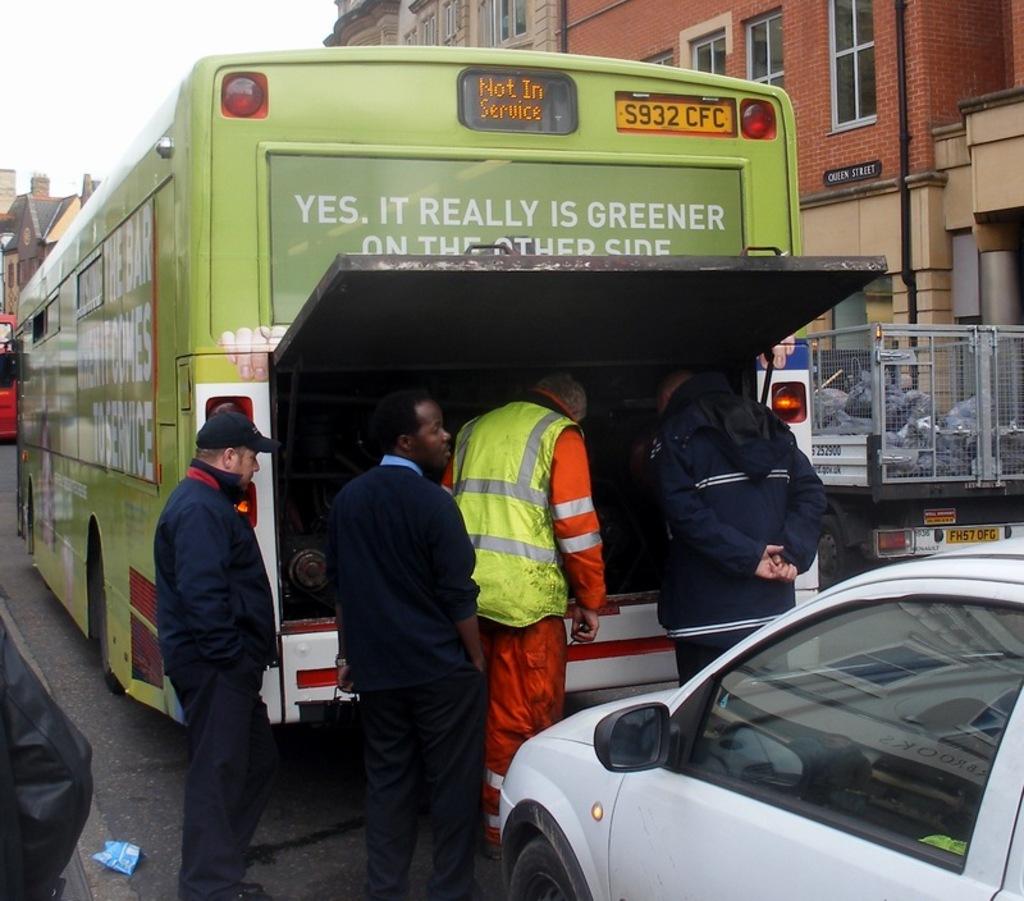What is the bus number on the top right of the front of the bus?
Offer a very short reply. S932 cfc. 